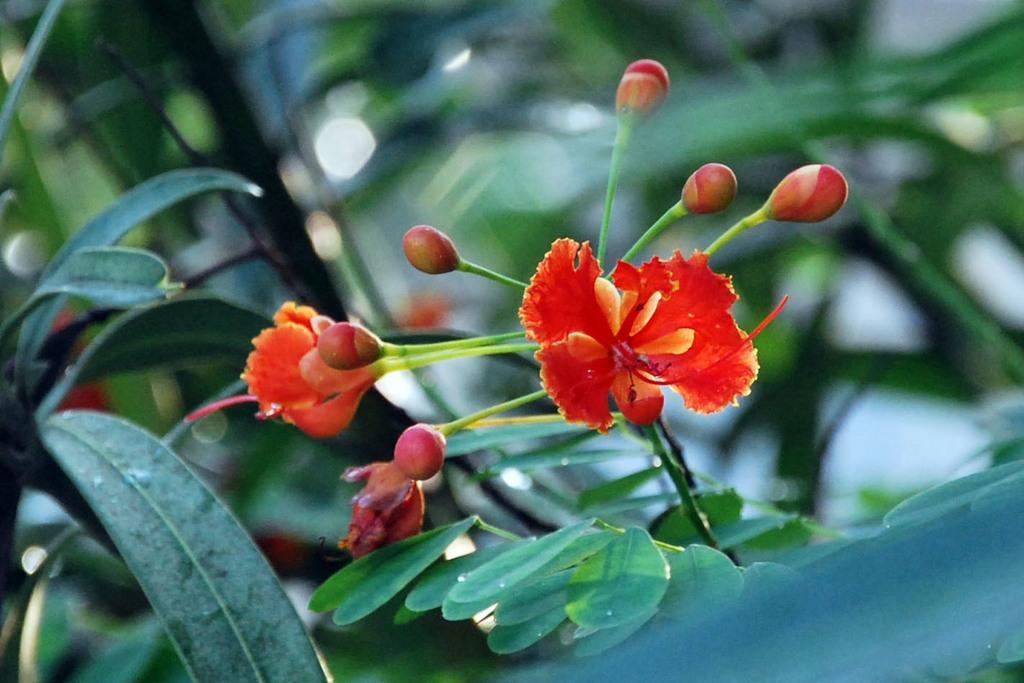What type of living organism is present in the image? There is a plant in the image. What color are the flowers on the plant? The flowers on the plant are red. Are there any unopened flowers on the plant? Yes, the plant has buds. How would you describe the background of the image? The background of the image is blurred. What type of loaf is being used as a prop in the image? There is no loaf present in the image. 